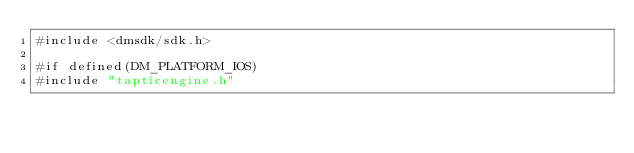<code> <loc_0><loc_0><loc_500><loc_500><_ObjectiveC_>#include <dmsdk/sdk.h>

#if defined(DM_PLATFORM_IOS)
#include "tapticengine.h"</code> 